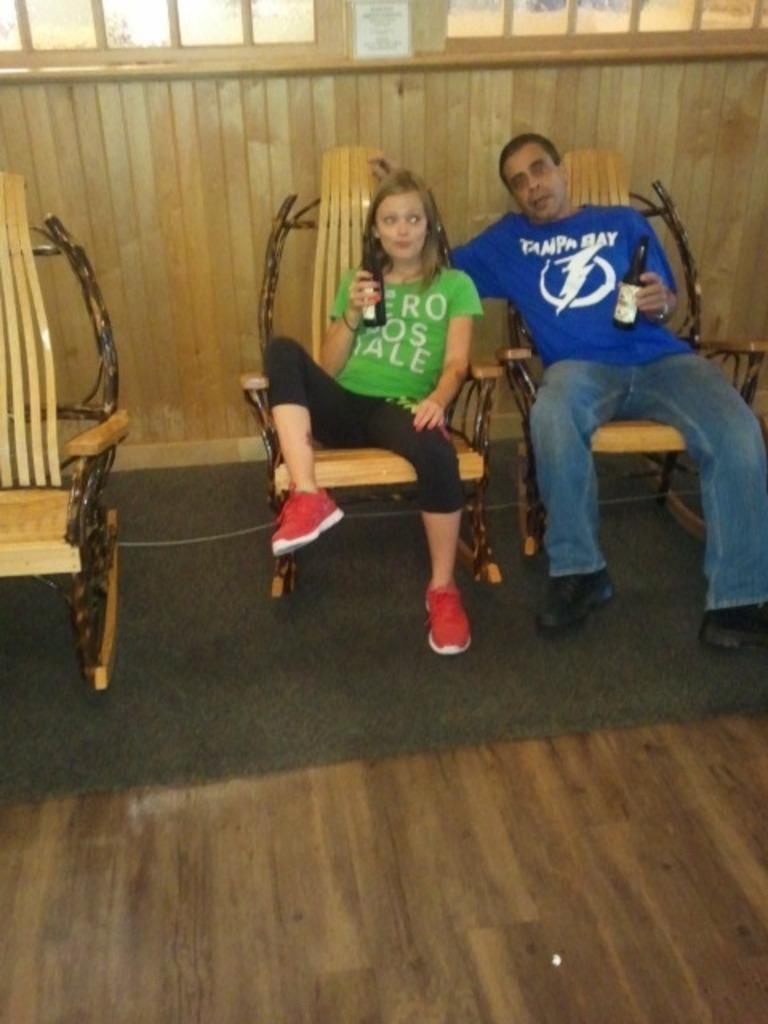In one or two sentences, can you explain what this image depicts? There are two person, who are sitting on a wooden chair. On the right there is a person, who is wearing a blue shirt and holding a wine bottle. On the left there is a women who is wearing a green t-shirt and red shoe. And she is holding a wine bottle. On the background we can see a wooden wall and a window. 